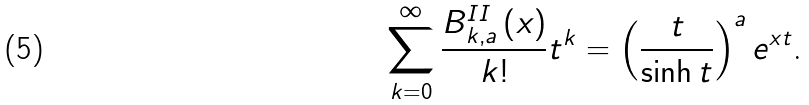<formula> <loc_0><loc_0><loc_500><loc_500>\sum _ { k = 0 } ^ { \infty } \frac { B _ { k , a } ^ { I I } \left ( x \right ) } { k ! } t ^ { k } = \left ( \frac { t } { \sinh t } \right ) ^ { a } e ^ { x t } \text {.}</formula> 